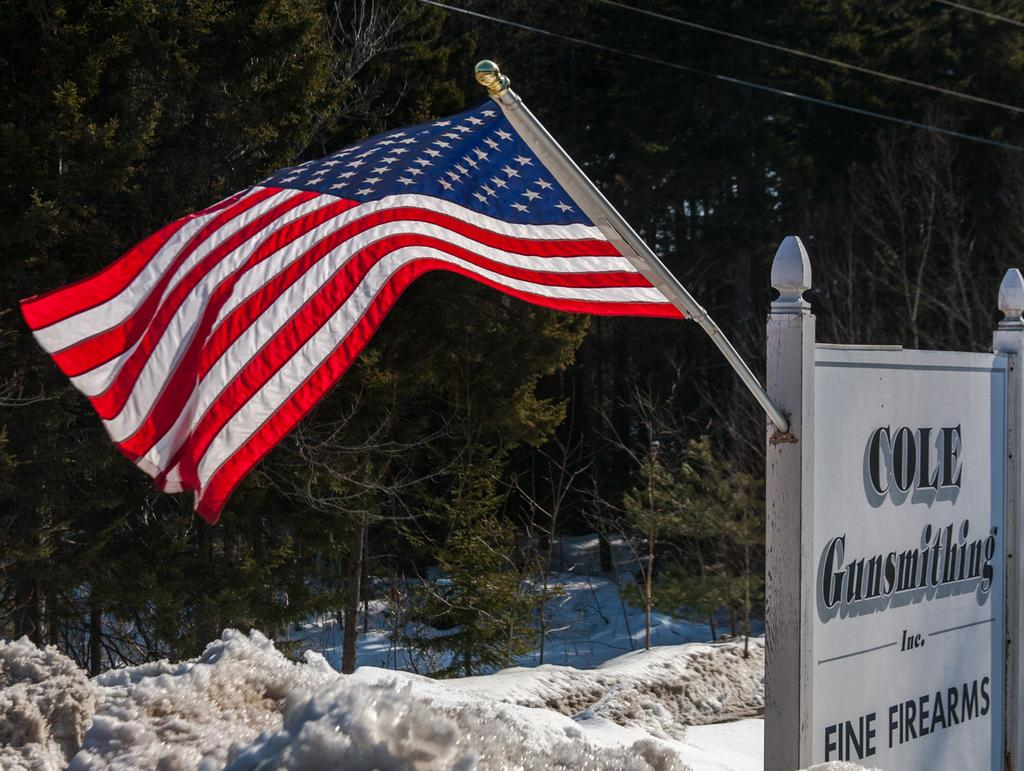What type of natural elements can be seen in the image? There are trees in the image. What man-made structures are present in the image? There are wires and a flag in the image. What is the state of the water in the image? There is water in the image. What is the texture of the ice in the image? There is ice in the image. What type of signage is present in the image? There is a truncated board with text in the image. What type of verse can be heard recited by the leg in the image? There is no leg or verse present in the image. 